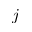<formula> <loc_0><loc_0><loc_500><loc_500>j</formula> 